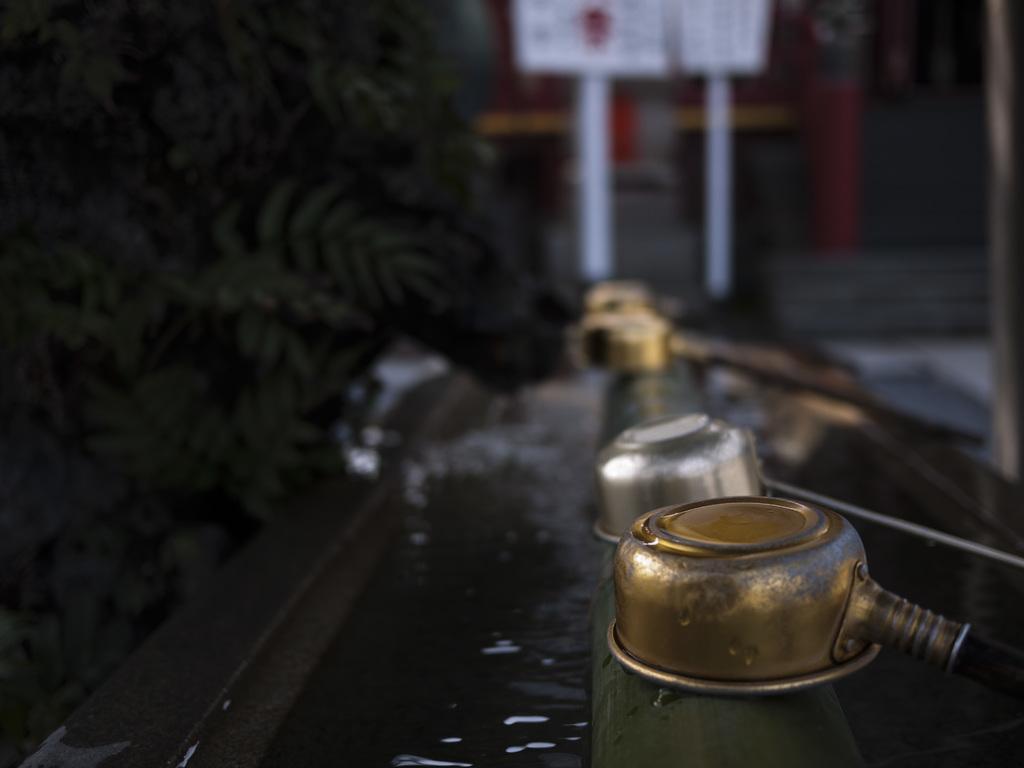In one or two sentences, can you explain what this image depicts? In this image we can see some silver and golden color things on pipe, on left side of the image there are some trees and in the background of the image there is a board. 